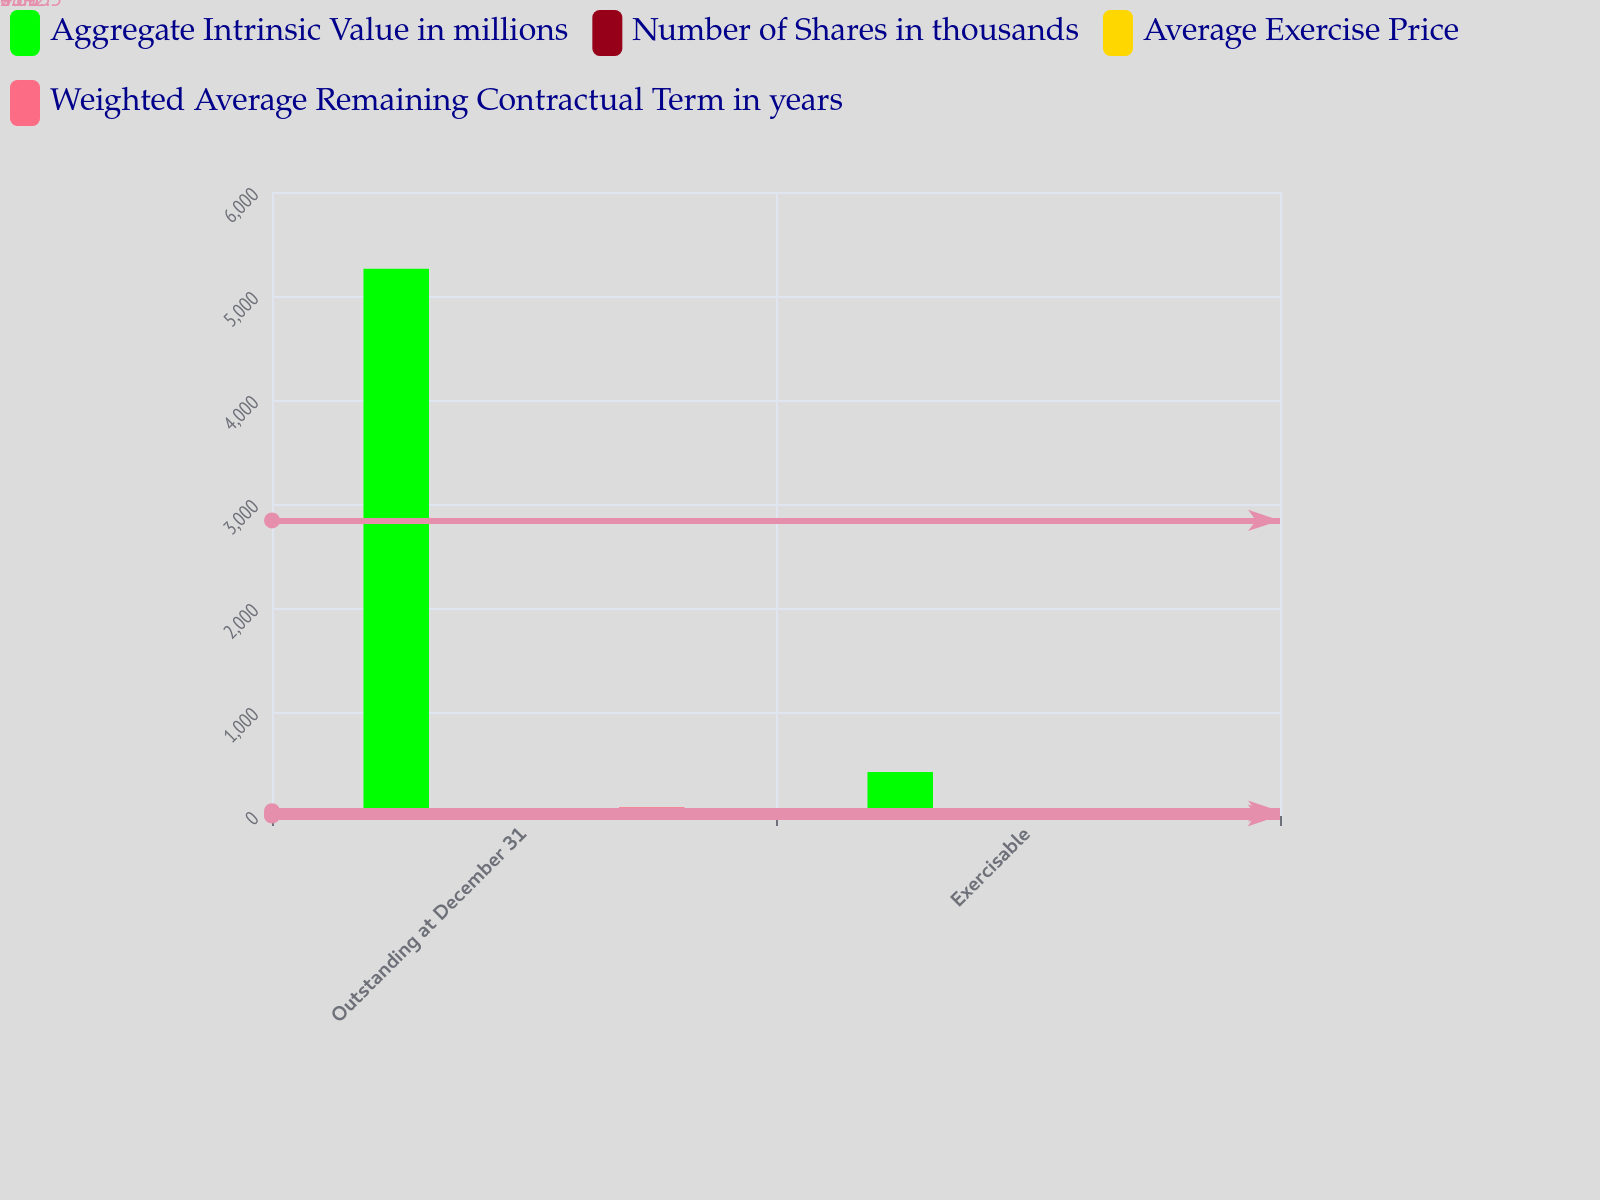Convert chart to OTSL. <chart><loc_0><loc_0><loc_500><loc_500><stacked_bar_chart><ecel><fcel>Outstanding at December 31<fcel>Exercisable<nl><fcel>Aggregate Intrinsic Value in millions<fcel>5262<fcel>423<nl><fcel>Number of Shares in thousands<fcel>10.49<fcel>7.22<nl><fcel>Average Exercise Price<fcel>4.95<fcel>4.27<nl><fcel>Weighted Average Remaining Contractual Term in years<fcel>83<fcel>8.1<nl></chart> 